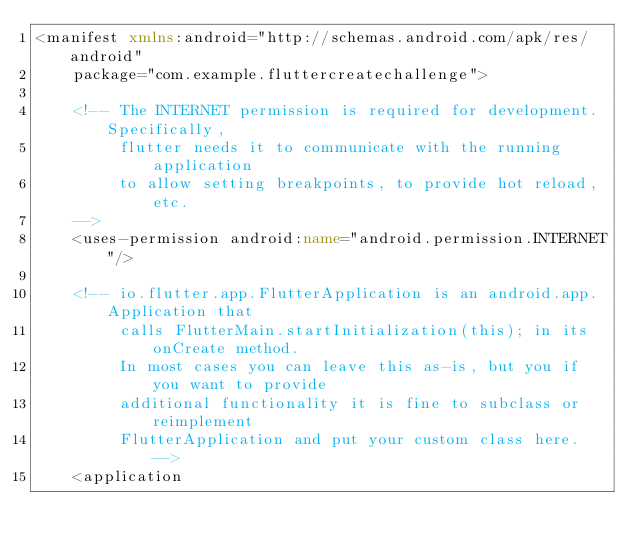<code> <loc_0><loc_0><loc_500><loc_500><_XML_><manifest xmlns:android="http://schemas.android.com/apk/res/android"
    package="com.example.fluttercreatechallenge">

    <!-- The INTERNET permission is required for development. Specifically,
         flutter needs it to communicate with the running application
         to allow setting breakpoints, to provide hot reload, etc.
    -->
    <uses-permission android:name="android.permission.INTERNET"/>

    <!-- io.flutter.app.FlutterApplication is an android.app.Application that
         calls FlutterMain.startInitialization(this); in its onCreate method.
         In most cases you can leave this as-is, but you if you want to provide
         additional functionality it is fine to subclass or reimplement
         FlutterApplication and put your custom class here. -->
    <application</code> 